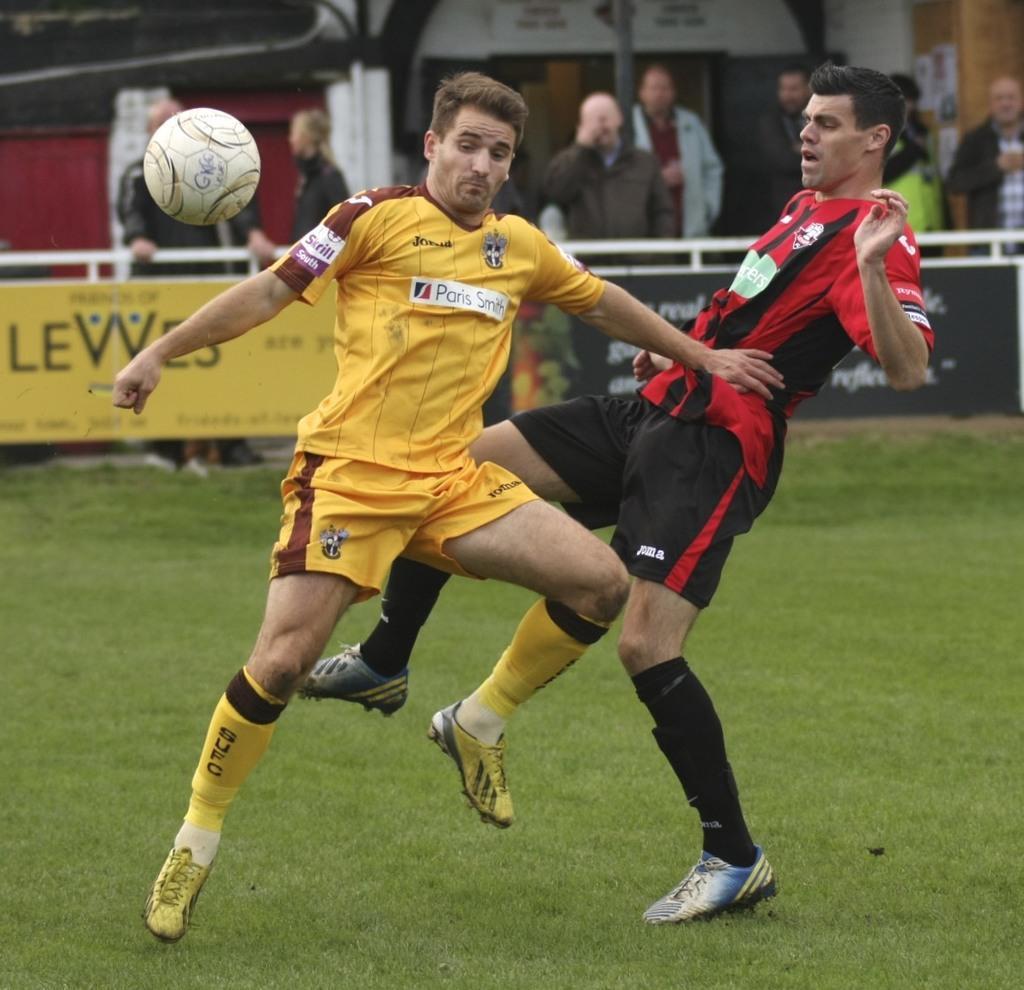Could you give a brief overview of what you see in this image? In this picture we can see two men are on the grass and a ball is in the air. In the background we can see some people, posters and some objects. 